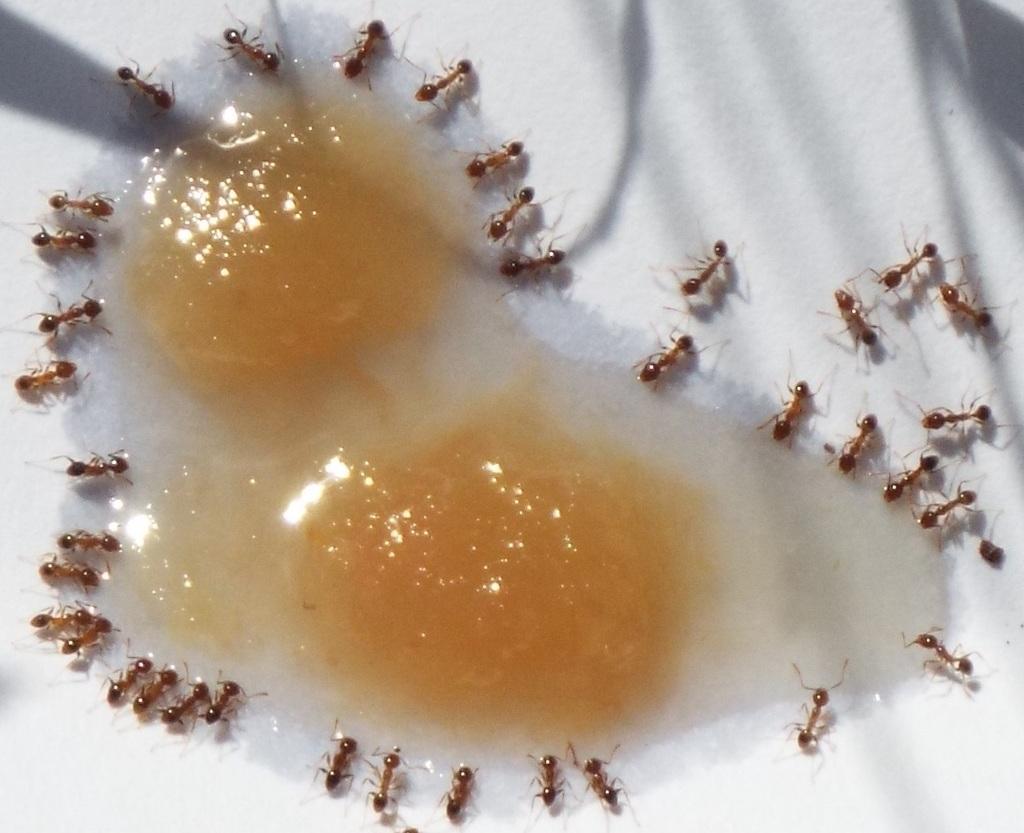Could you give a brief overview of what you see in this image? We can see food and ants on the white surface. 